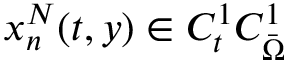Convert formula to latex. <formula><loc_0><loc_0><loc_500><loc_500>x _ { n } ^ { N } ( t , y ) \in C _ { t } ^ { 1 } C _ { \ B a r { \Omega } } ^ { 1 }</formula> 